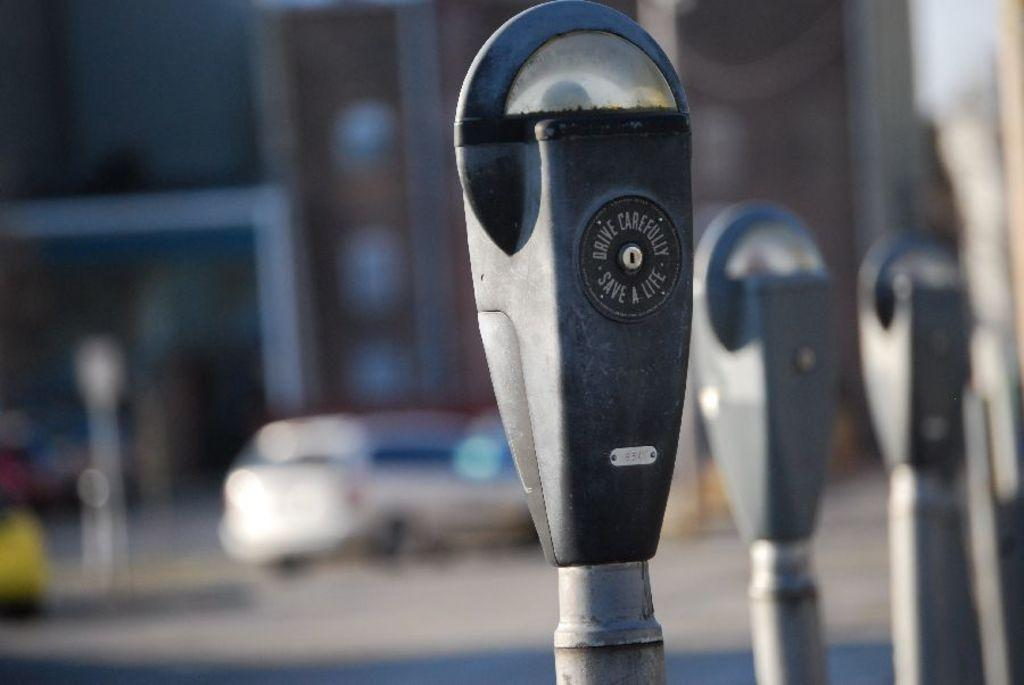<image>
Provide a brief description of the given image. A parking meter says to drive carefully, save a life. 